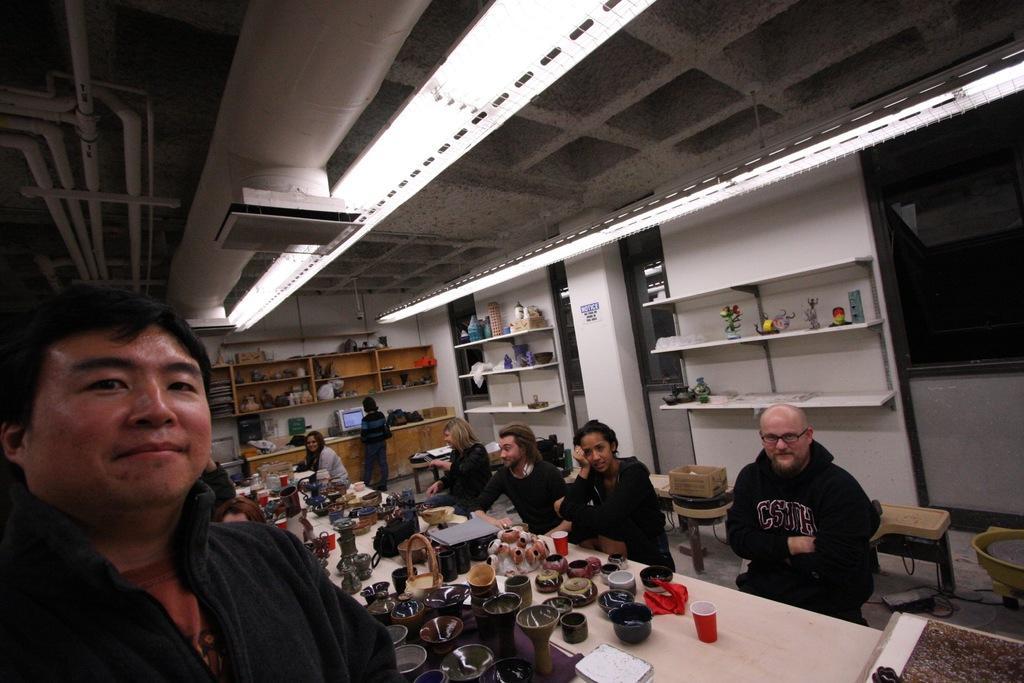How would you summarize this image in a sentence or two? In this image we can see the people. We can also see the table and on the table we can see the bowls, cups and also some other objects. In the background we can see the monitor on the counter. We can also see some racks with the objects. We can also see the floor and at the top we can see the ceiling with the ceiling lights. 